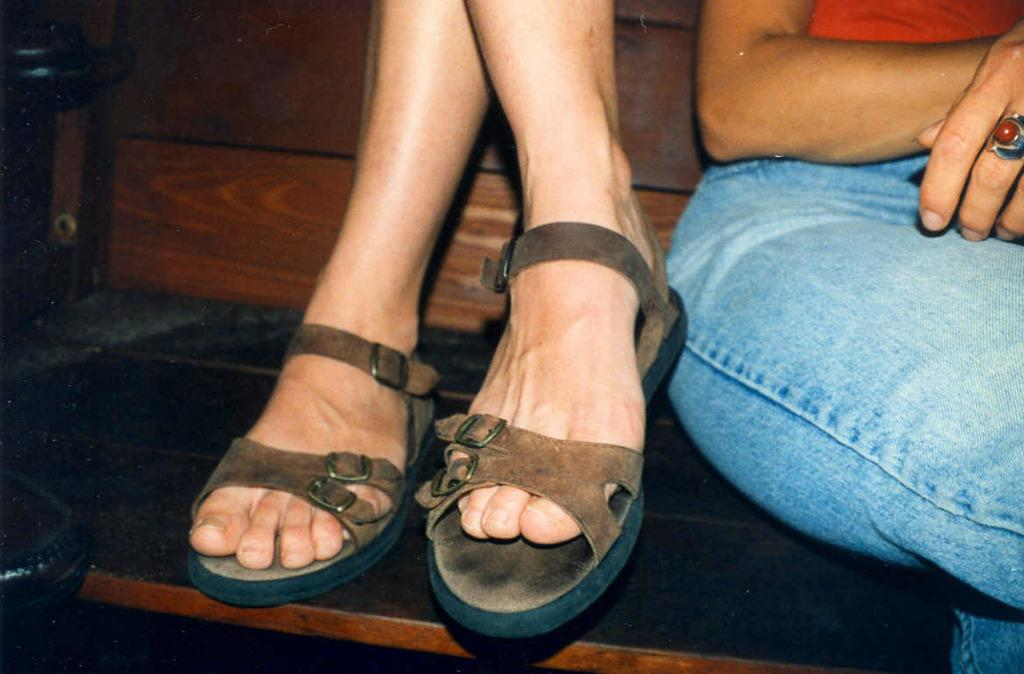What is located on the right side of the image? There is a person on the right side of the image. Can you describe any other body part visible in the image? Yes, there is a foot of another person visible in the image. What type of object is on the left side of the image? There is a wooden object on the left side of the image. What type of music can be heard coming from the crowd in the image? There is no crowd present in the image, so it's not possible to determine what, if any, music might be heard. 